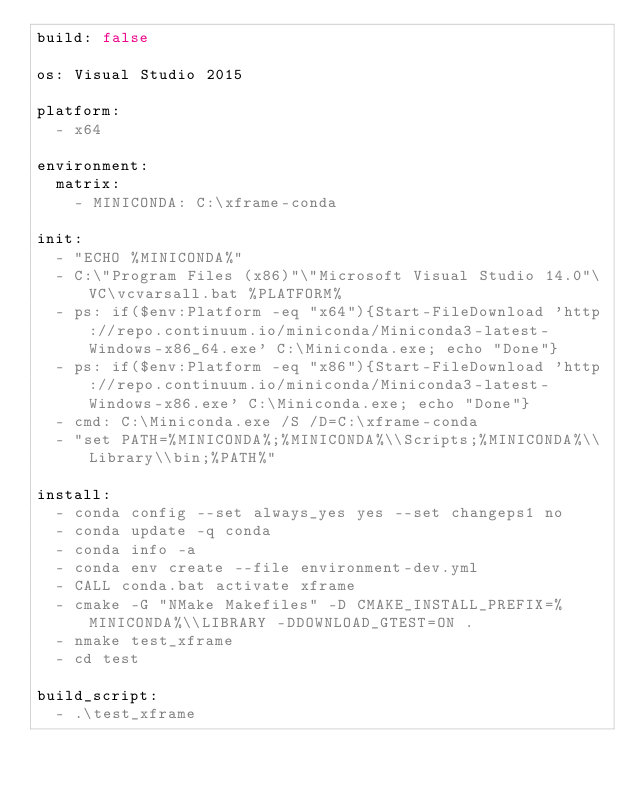Convert code to text. <code><loc_0><loc_0><loc_500><loc_500><_YAML_>build: false

os: Visual Studio 2015

platform:
  - x64

environment:
  matrix:
    - MINICONDA: C:\xframe-conda

init:
  - "ECHO %MINICONDA%"
  - C:\"Program Files (x86)"\"Microsoft Visual Studio 14.0"\VC\vcvarsall.bat %PLATFORM%
  - ps: if($env:Platform -eq "x64"){Start-FileDownload 'http://repo.continuum.io/miniconda/Miniconda3-latest-Windows-x86_64.exe' C:\Miniconda.exe; echo "Done"}
  - ps: if($env:Platform -eq "x86"){Start-FileDownload 'http://repo.continuum.io/miniconda/Miniconda3-latest-Windows-x86.exe' C:\Miniconda.exe; echo "Done"}
  - cmd: C:\Miniconda.exe /S /D=C:\xframe-conda
  - "set PATH=%MINICONDA%;%MINICONDA%\\Scripts;%MINICONDA%\\Library\\bin;%PATH%"

install:
  - conda config --set always_yes yes --set changeps1 no
  - conda update -q conda
  - conda info -a
  - conda env create --file environment-dev.yml
  - CALL conda.bat activate xframe
  - cmake -G "NMake Makefiles" -D CMAKE_INSTALL_PREFIX=%MINICONDA%\\LIBRARY -DDOWNLOAD_GTEST=ON .
  - nmake test_xframe
  - cd test

build_script:
  - .\test_xframe
</code> 